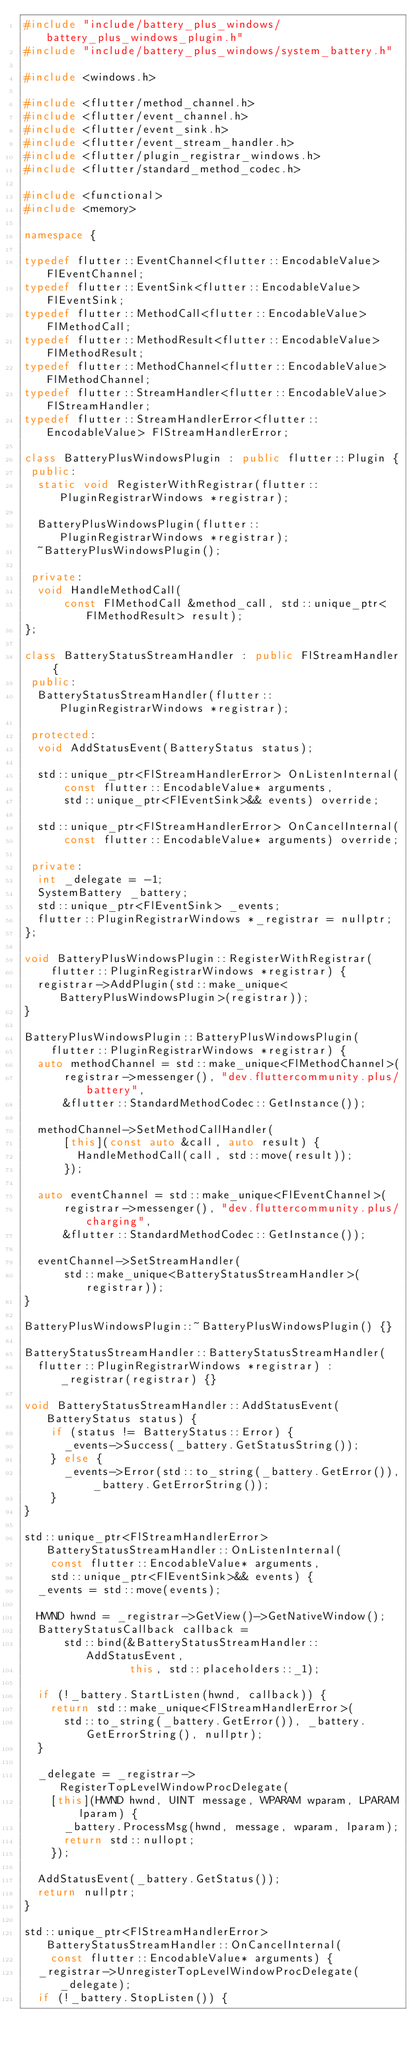Convert code to text. <code><loc_0><loc_0><loc_500><loc_500><_C++_>#include "include/battery_plus_windows/battery_plus_windows_plugin.h"
#include "include/battery_plus_windows/system_battery.h"

#include <windows.h>

#include <flutter/method_channel.h>
#include <flutter/event_channel.h>
#include <flutter/event_sink.h>
#include <flutter/event_stream_handler.h>
#include <flutter/plugin_registrar_windows.h>
#include <flutter/standard_method_codec.h>

#include <functional>
#include <memory>

namespace {

typedef flutter::EventChannel<flutter::EncodableValue> FlEventChannel;
typedef flutter::EventSink<flutter::EncodableValue> FlEventSink;
typedef flutter::MethodCall<flutter::EncodableValue> FlMethodCall;
typedef flutter::MethodResult<flutter::EncodableValue> FlMethodResult;
typedef flutter::MethodChannel<flutter::EncodableValue> FlMethodChannel;
typedef flutter::StreamHandler<flutter::EncodableValue> FlStreamHandler;
typedef flutter::StreamHandlerError<flutter::EncodableValue> FlStreamHandlerError;

class BatteryPlusWindowsPlugin : public flutter::Plugin {
 public:
  static void RegisterWithRegistrar(flutter::PluginRegistrarWindows *registrar);

  BatteryPlusWindowsPlugin(flutter::PluginRegistrarWindows *registrar);
  ~BatteryPlusWindowsPlugin();

 private:
  void HandleMethodCall(
      const FlMethodCall &method_call, std::unique_ptr<FlMethodResult> result);
};

class BatteryStatusStreamHandler : public FlStreamHandler {
 public:
  BatteryStatusStreamHandler(flutter::PluginRegistrarWindows *registrar);

 protected:
  void AddStatusEvent(BatteryStatus status);

  std::unique_ptr<FlStreamHandlerError> OnListenInternal(
      const flutter::EncodableValue* arguments,
      std::unique_ptr<FlEventSink>&& events) override;

  std::unique_ptr<FlStreamHandlerError> OnCancelInternal(
      const flutter::EncodableValue* arguments) override;

 private:
  int _delegate = -1;
  SystemBattery _battery;
  std::unique_ptr<FlEventSink> _events;
  flutter::PluginRegistrarWindows *_registrar = nullptr;
};

void BatteryPlusWindowsPlugin::RegisterWithRegistrar(
    flutter::PluginRegistrarWindows *registrar) {
  registrar->AddPlugin(std::make_unique<BatteryPlusWindowsPlugin>(registrar));
}

BatteryPlusWindowsPlugin::BatteryPlusWindowsPlugin(
    flutter::PluginRegistrarWindows *registrar) {
  auto methodChannel = std::make_unique<FlMethodChannel>(
      registrar->messenger(), "dev.fluttercommunity.plus/battery",
      &flutter::StandardMethodCodec::GetInstance());

  methodChannel->SetMethodCallHandler(
      [this](const auto &call, auto result) {
        HandleMethodCall(call, std::move(result));
      });

  auto eventChannel = std::make_unique<FlEventChannel>(
      registrar->messenger(), "dev.fluttercommunity.plus/charging",
      &flutter::StandardMethodCodec::GetInstance());

  eventChannel->SetStreamHandler(
      std::make_unique<BatteryStatusStreamHandler>(registrar));
}

BatteryPlusWindowsPlugin::~BatteryPlusWindowsPlugin() {}

BatteryStatusStreamHandler::BatteryStatusStreamHandler(
  flutter::PluginRegistrarWindows *registrar) : _registrar(registrar) {}

void BatteryStatusStreamHandler::AddStatusEvent(BatteryStatus status) {
    if (status != BatteryStatus::Error) {
      _events->Success(_battery.GetStatusString());
    } else {
      _events->Error(std::to_string(_battery.GetError()), _battery.GetErrorString());
    }
}

std::unique_ptr<FlStreamHandlerError> BatteryStatusStreamHandler::OnListenInternal(
    const flutter::EncodableValue* arguments,
    std::unique_ptr<FlEventSink>&& events) {
  _events = std::move(events);

  HWND hwnd = _registrar->GetView()->GetNativeWindow();
  BatteryStatusCallback callback =
      std::bind(&BatteryStatusStreamHandler::AddStatusEvent,
                this, std::placeholders::_1);

  if (!_battery.StartListen(hwnd, callback)) {
    return std::make_unique<FlStreamHandlerError>(
      std::to_string(_battery.GetError()), _battery.GetErrorString(), nullptr);
  }

  _delegate = _registrar->RegisterTopLevelWindowProcDelegate(
    [this](HWND hwnd, UINT message, WPARAM wparam, LPARAM lparam) {
      _battery.ProcessMsg(hwnd, message, wparam, lparam);
      return std::nullopt;
    });

  AddStatusEvent(_battery.GetStatus());
  return nullptr;
}

std::unique_ptr<FlStreamHandlerError> BatteryStatusStreamHandler::OnCancelInternal(
    const flutter::EncodableValue* arguments) {
  _registrar->UnregisterTopLevelWindowProcDelegate(_delegate);
  if (!_battery.StopListen()) {</code> 